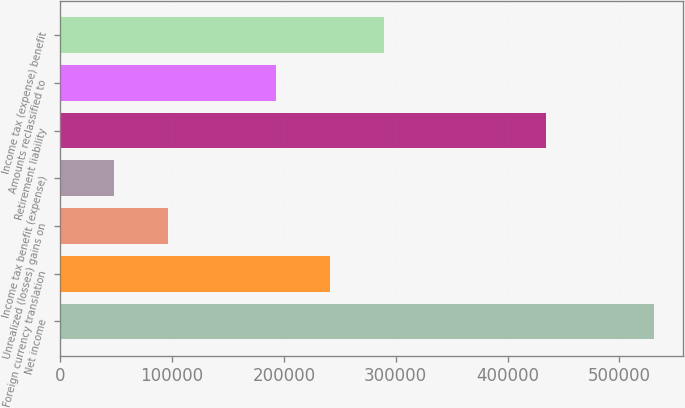Convert chart. <chart><loc_0><loc_0><loc_500><loc_500><bar_chart><fcel>Net income<fcel>Foreign currency translation<fcel>Unrealized (losses) gains on<fcel>Income tax benefit (expense)<fcel>Retirement liability<fcel>Amounts reclassified to<fcel>Income tax (expense) benefit<nl><fcel>530491<fcel>241206<fcel>96562.6<fcel>48348.3<fcel>434063<fcel>192991<fcel>289420<nl></chart> 